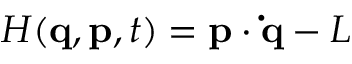Convert formula to latex. <formula><loc_0><loc_0><loc_500><loc_500>H ( q , p , t ) = p \cdot \dot { q } - L</formula> 